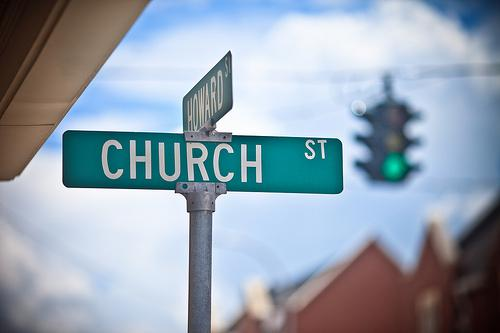Question: what is in the sky?
Choices:
A. Stars.
B. Airplane.
C. Birds.
D. Clouds.
Answer with the letter. Answer: D Question: where are clouds?
Choices:
A. Above.
B. In the sky.
C. Over the field.
D. Over the town.
Answer with the letter. Answer: B Question: what is blue?
Choices:
A. Ocean.
B. Lake.
C. Sky.
D. Sweater.
Answer with the letter. Answer: C Question: when was the picture taken?
Choices:
A. Morning.
B. At sunrise.
C. Daytime.
D. Afternoon.
Answer with the letter. Answer: C Question: what is lit green?
Choices:
A. Lamp.
B. LED light.
C. Traffic light.
D. Fish tank.
Answer with the letter. Answer: C Question: what is brown?
Choices:
A. Trees.
B. A building.
C. Logs.
D. Barn.
Answer with the letter. Answer: B 